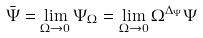Convert formula to latex. <formula><loc_0><loc_0><loc_500><loc_500>\bar { \Psi } = \lim _ { \Omega \to 0 } \Psi _ { \Omega } = \lim _ { \Omega \to 0 } \Omega ^ { \Delta _ { \Psi } } \Psi</formula> 